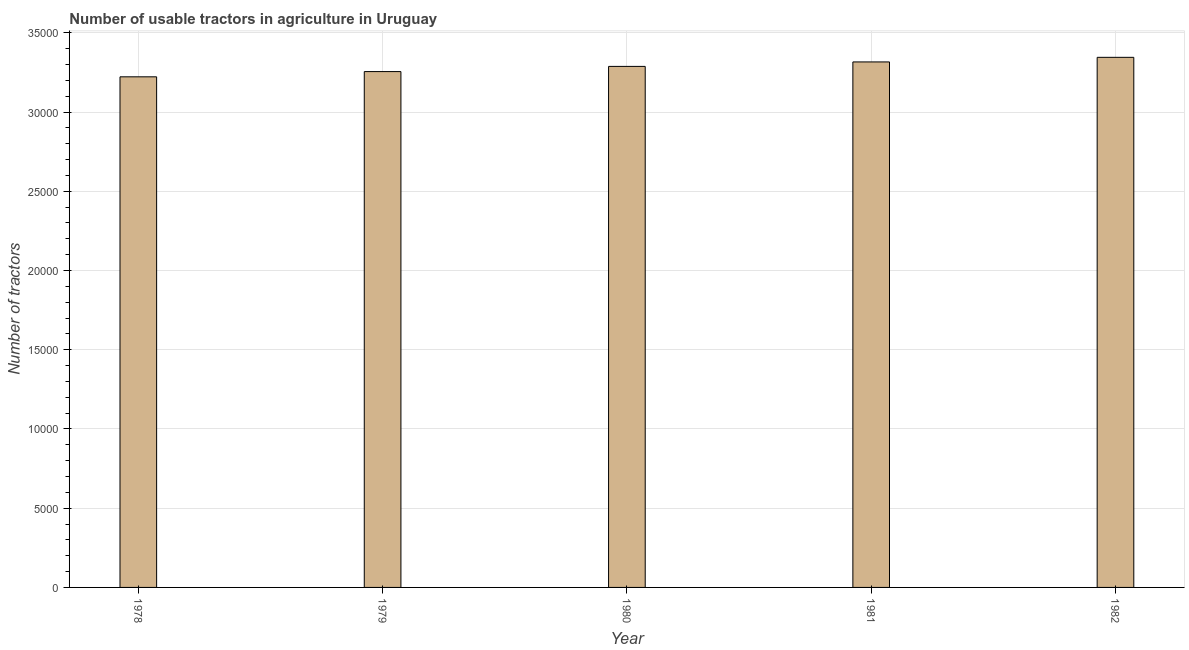Does the graph contain grids?
Your answer should be very brief. Yes. What is the title of the graph?
Keep it short and to the point. Number of usable tractors in agriculture in Uruguay. What is the label or title of the X-axis?
Give a very brief answer. Year. What is the label or title of the Y-axis?
Provide a succinct answer. Number of tractors. What is the number of tractors in 1981?
Ensure brevity in your answer.  3.32e+04. Across all years, what is the maximum number of tractors?
Give a very brief answer. 3.34e+04. Across all years, what is the minimum number of tractors?
Keep it short and to the point. 3.22e+04. In which year was the number of tractors minimum?
Give a very brief answer. 1978. What is the sum of the number of tractors?
Keep it short and to the point. 1.64e+05. What is the difference between the number of tractors in 1979 and 1981?
Your answer should be compact. -610. What is the average number of tractors per year?
Provide a short and direct response. 3.29e+04. What is the median number of tractors?
Give a very brief answer. 3.29e+04. In how many years, is the number of tractors greater than 10000 ?
Give a very brief answer. 5. Do a majority of the years between 1979 and 1978 (inclusive) have number of tractors greater than 30000 ?
Provide a short and direct response. No. What is the ratio of the number of tractors in 1980 to that in 1982?
Provide a short and direct response. 0.98. Is the number of tractors in 1978 less than that in 1981?
Your answer should be compact. Yes. Is the difference between the number of tractors in 1980 and 1982 greater than the difference between any two years?
Keep it short and to the point. No. What is the difference between the highest and the second highest number of tractors?
Ensure brevity in your answer.  290. What is the difference between the highest and the lowest number of tractors?
Your answer should be very brief. 1230. Are all the bars in the graph horizontal?
Ensure brevity in your answer.  No. What is the difference between two consecutive major ticks on the Y-axis?
Your answer should be compact. 5000. What is the Number of tractors in 1978?
Provide a succinct answer. 3.22e+04. What is the Number of tractors of 1979?
Ensure brevity in your answer.  3.26e+04. What is the Number of tractors of 1980?
Keep it short and to the point. 3.29e+04. What is the Number of tractors of 1981?
Offer a very short reply. 3.32e+04. What is the Number of tractors of 1982?
Keep it short and to the point. 3.34e+04. What is the difference between the Number of tractors in 1978 and 1979?
Ensure brevity in your answer.  -330. What is the difference between the Number of tractors in 1978 and 1980?
Offer a very short reply. -658. What is the difference between the Number of tractors in 1978 and 1981?
Your answer should be compact. -940. What is the difference between the Number of tractors in 1978 and 1982?
Provide a succinct answer. -1230. What is the difference between the Number of tractors in 1979 and 1980?
Provide a succinct answer. -328. What is the difference between the Number of tractors in 1979 and 1981?
Offer a terse response. -610. What is the difference between the Number of tractors in 1979 and 1982?
Provide a succinct answer. -900. What is the difference between the Number of tractors in 1980 and 1981?
Your response must be concise. -282. What is the difference between the Number of tractors in 1980 and 1982?
Give a very brief answer. -572. What is the difference between the Number of tractors in 1981 and 1982?
Provide a short and direct response. -290. What is the ratio of the Number of tractors in 1978 to that in 1980?
Your answer should be very brief. 0.98. What is the ratio of the Number of tractors in 1978 to that in 1981?
Your answer should be very brief. 0.97. What is the ratio of the Number of tractors in 1978 to that in 1982?
Offer a terse response. 0.96. What is the ratio of the Number of tractors in 1979 to that in 1982?
Your response must be concise. 0.97. What is the ratio of the Number of tractors in 1980 to that in 1981?
Offer a very short reply. 0.99. What is the ratio of the Number of tractors in 1981 to that in 1982?
Give a very brief answer. 0.99. 